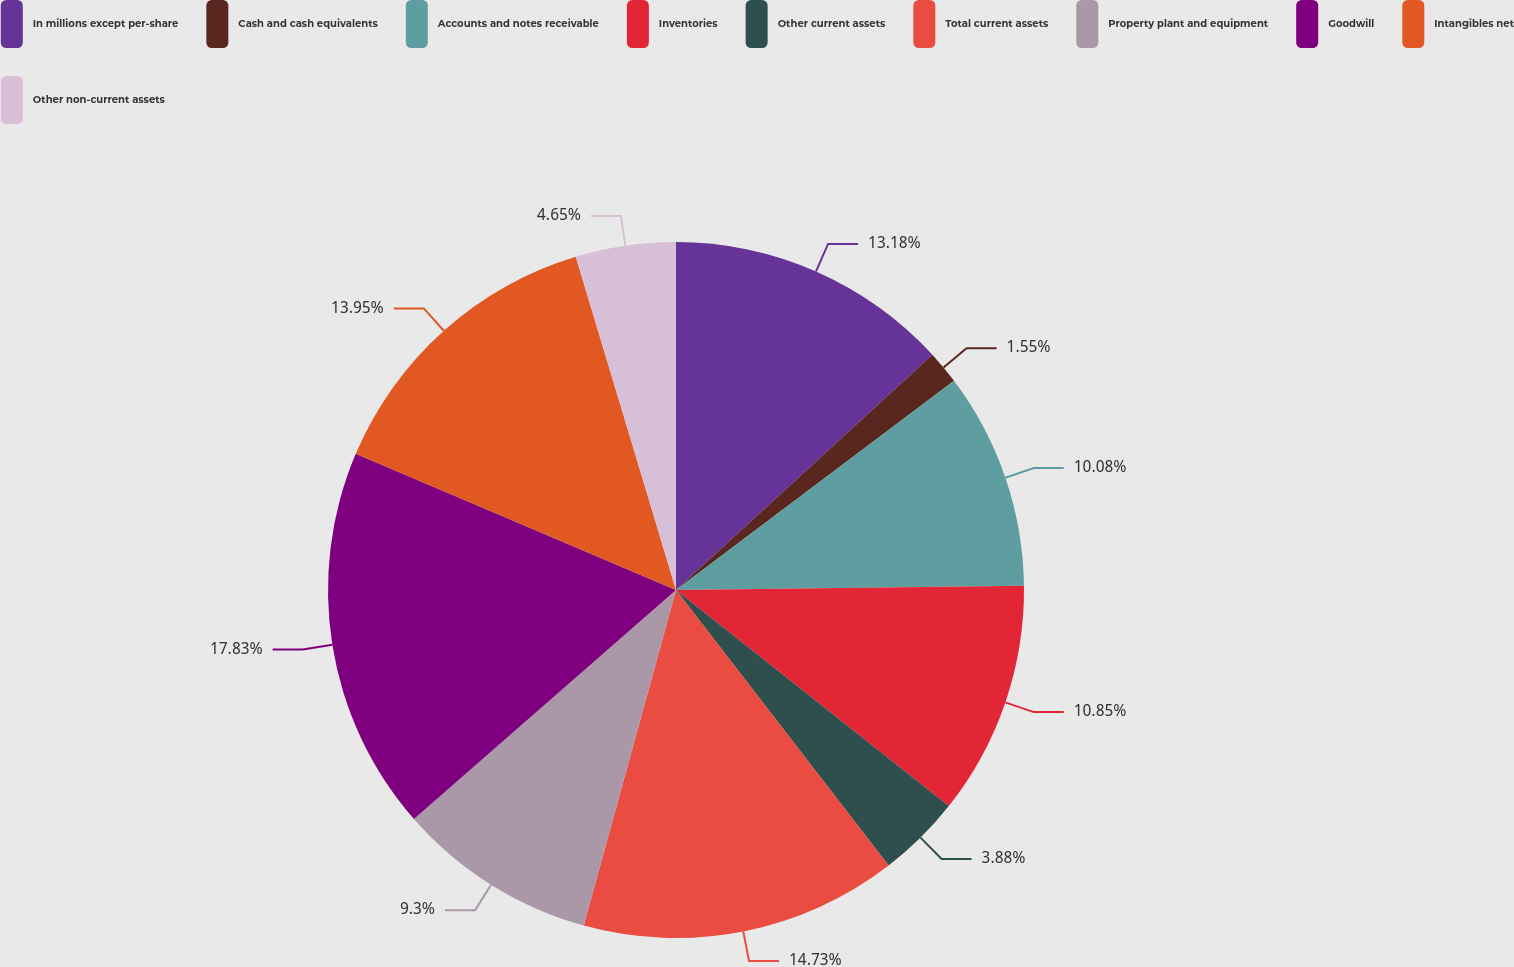<chart> <loc_0><loc_0><loc_500><loc_500><pie_chart><fcel>In millions except per-share<fcel>Cash and cash equivalents<fcel>Accounts and notes receivable<fcel>Inventories<fcel>Other current assets<fcel>Total current assets<fcel>Property plant and equipment<fcel>Goodwill<fcel>Intangibles net<fcel>Other non-current assets<nl><fcel>13.18%<fcel>1.55%<fcel>10.08%<fcel>10.85%<fcel>3.88%<fcel>14.73%<fcel>9.3%<fcel>17.83%<fcel>13.95%<fcel>4.65%<nl></chart> 